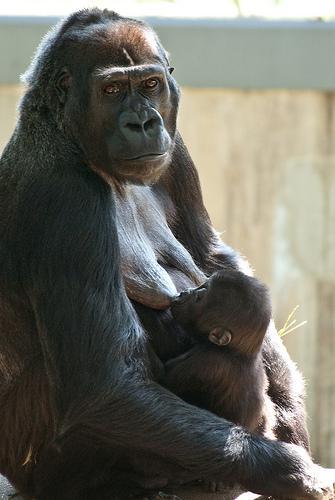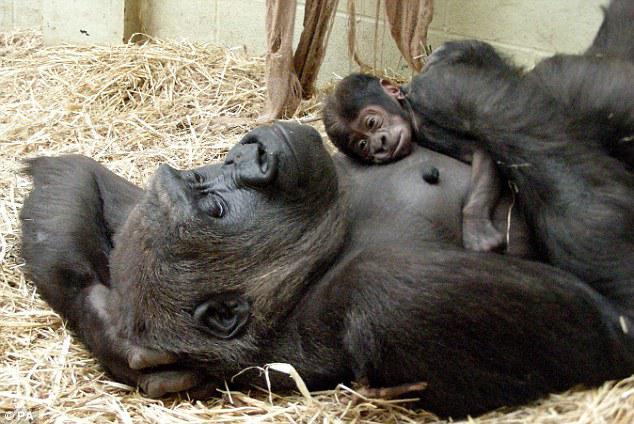The first image is the image on the left, the second image is the image on the right. For the images displayed, is the sentence "The left image shows a mother gorilla nursing her baby, sitting with her back to the left and her head raised and turned to gaze somewhat forward." factually correct? Answer yes or no. Yes. 